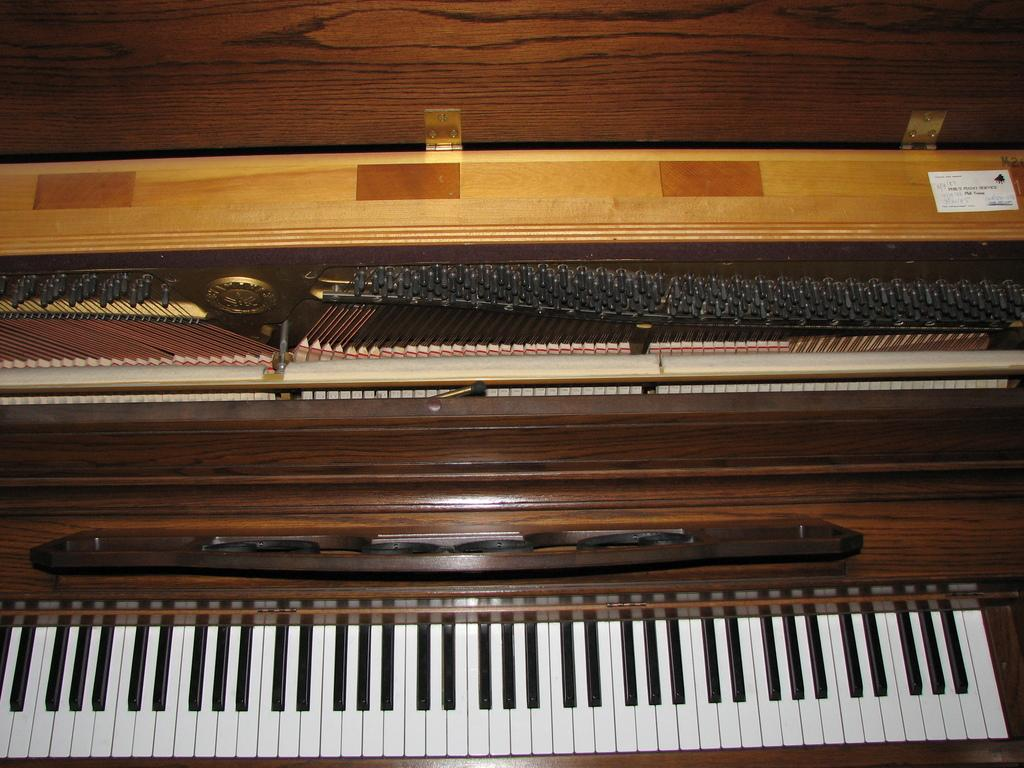What type of musical instrument is in the image? The musical instrument in the image resembles a keyboard. How is the keyboard structured? The keyboard has a box-like structure. What material is the box made of? The box is made of wood. How is the keyboard positioned in the image? The keyboard is placed inside the wooden box. What time of day is it in the image, and is the beginner practicing with the rake? The time of day is not mentioned in the image, and there is no rake present in the image. 